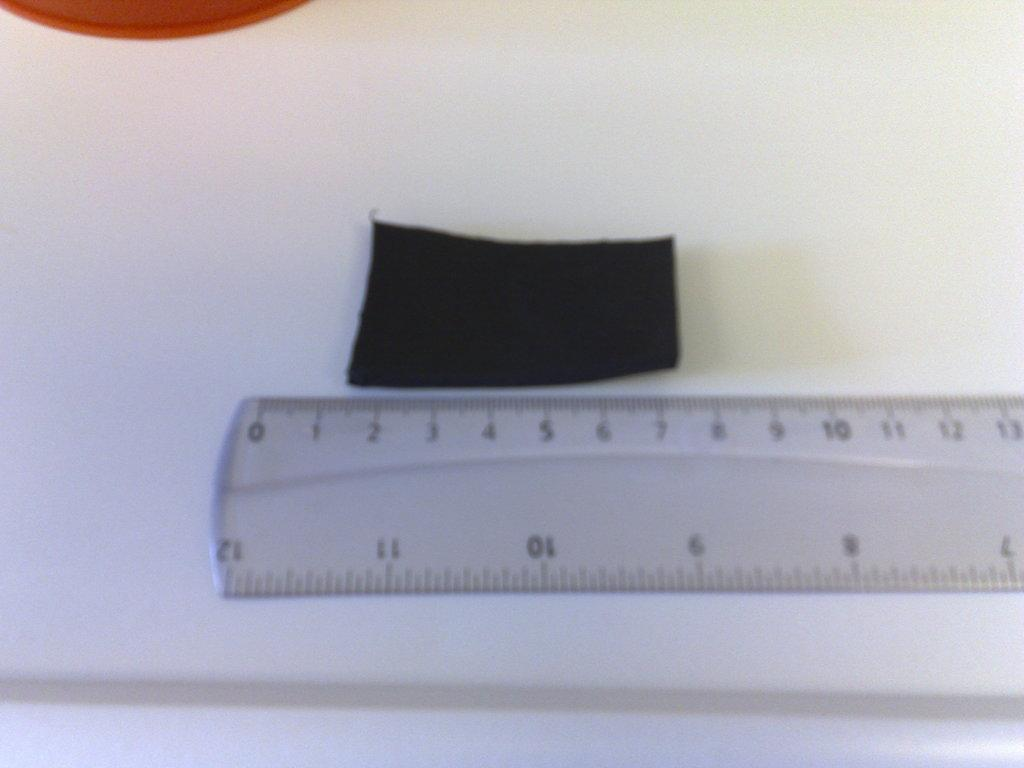<image>
Describe the image concisely. black rectangle that is about 6 cm next to a clear ruler 